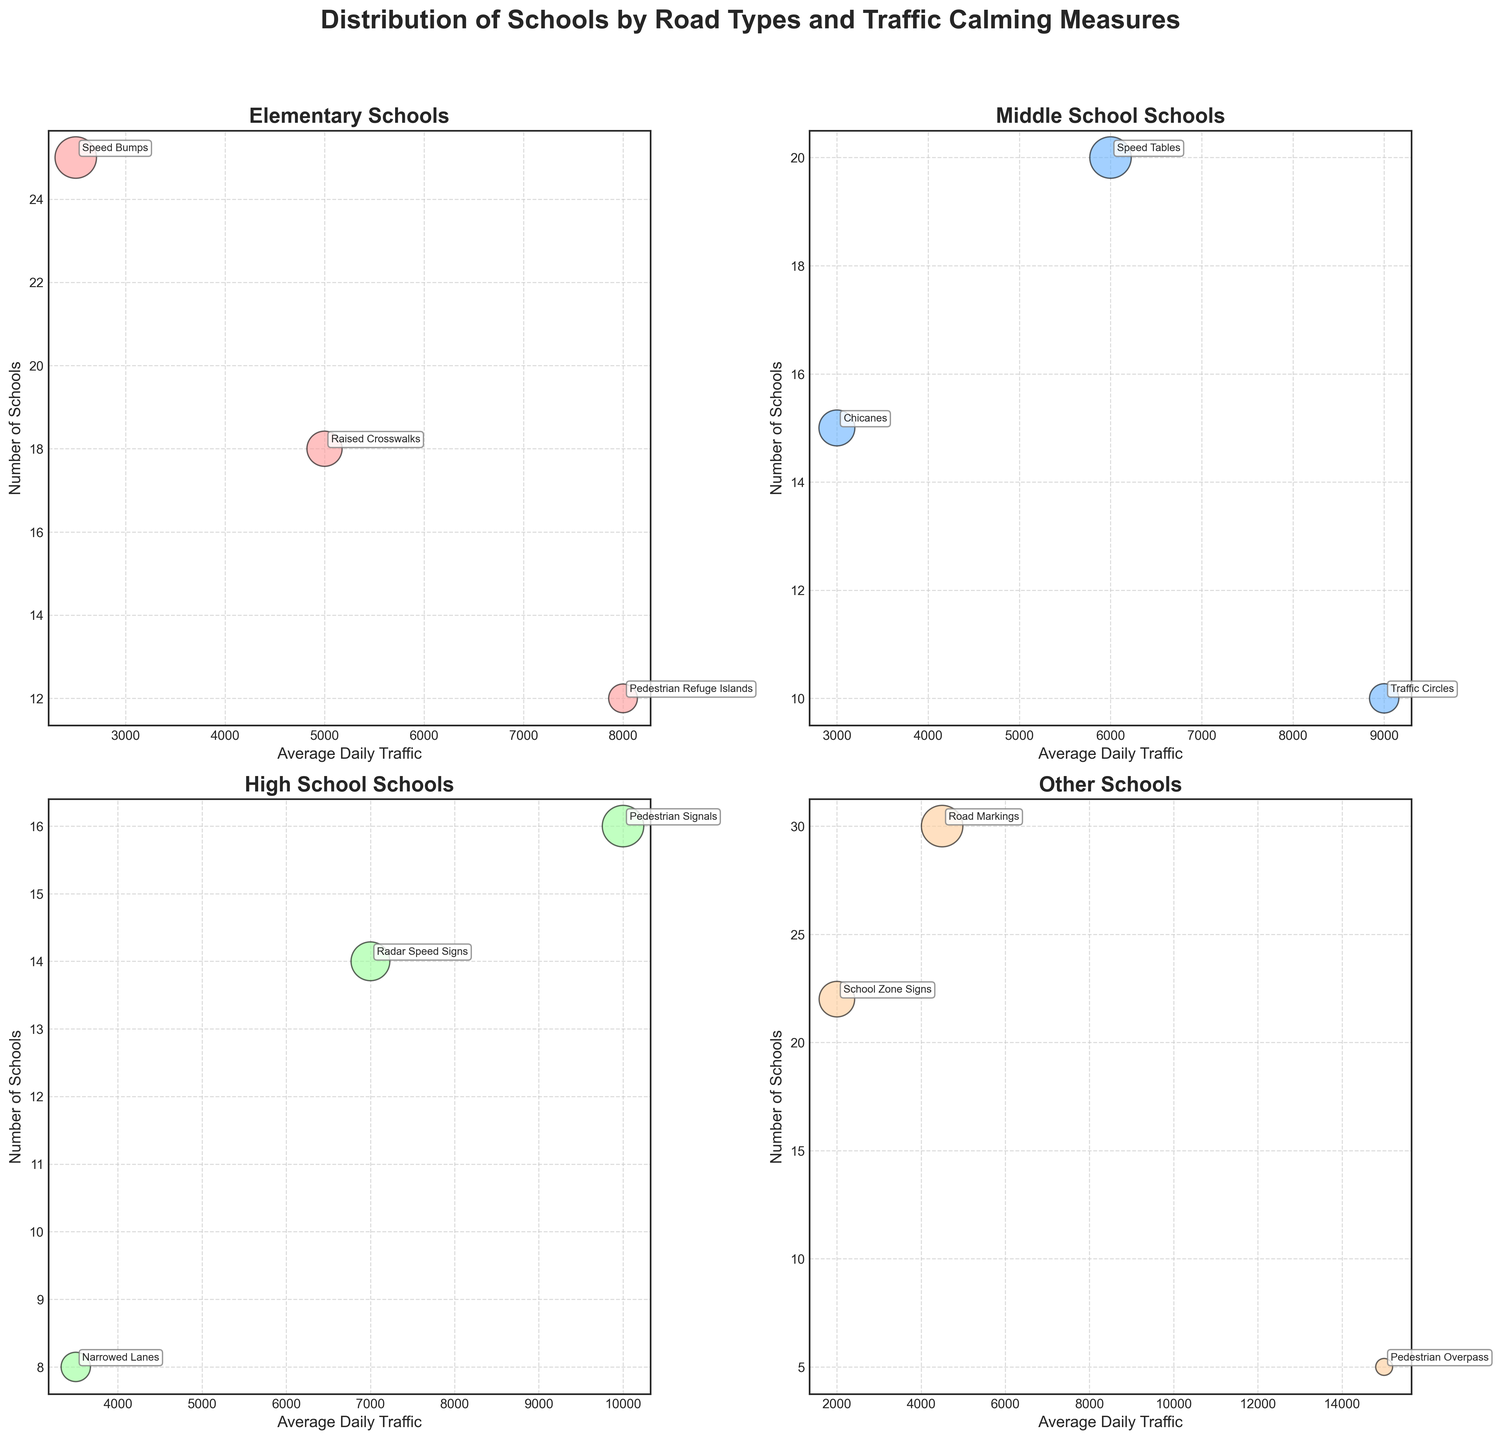What is the title of the figure? The title of the figure is located at the top and it is typically in a larger and bolder font to highlight its importance.
Answer: Distribution of Schools by Road Types and Traffic Calming Measures How many types of schools are represented? Different types of schools are indicated in the figure, each with its own sub-plot title. Counting these titles will give the number of school types.
Answer: Four Which road type has the highest average daily traffic? By scanning the x-axes across all sub-plots, identify the road type with the highest value on the average daily traffic scale.
Answer: Highway What traffic calming measure is used most frequently for Middle Schools? This can be determined by looking at the y-axis values in the Middle Schools sub-plot and checking the annotation on bubbles with the highest 'Number of Schools'.
Answer: Speed Tables Compare the number of high schools on residential streets to those on arterial roads. By looking at the High Schools sub-plot, compare the size of the bubbles (which indicates numbers) and the y-axis values for both Residential Streets and Arterial Roads.
Answer: 8 on Residential Streets, 16 on Arterial Roads Which type of school has the most types of road environments represented in the plots? By counting the unique road types mentioned in each sub-plot, determine which type of school has the widest variety.
Answer: Elementary For which school type does the traffic calming measure with the greatest number of schools appear? Identify which sub-plot has the largest bubble, then check the y-axis value and the associated traffic calming measure.
Answer: Secondary How does the use of pedestrian-related traffic calming measures compare between elementary and high schools? Look for annotated traffic calming measures related to pedestrians (e.g., Pedestrian Refuge Islands, Pedestrian Signals) in both Elementary and High Schools sub-plots and compare the bubble sizes/y-axis values.
Answer: Elementary: Pedestrian Refuge Islands (12), High School: Pedestrian Signals (16) What is the traffic calming measure used on the highway, and what is its corresponding average daily traffic? Refer to the sub-plot discussing non-standard school types (Others) and look at the annotations and x-axis values for the bubble representing the highway.
Answer: Pedestrian Overpass, 15,000 Which type of road is associated with the greatest number of schools in the Secondary school category? Refer to the Secondary school sub-plot and identify the road type corresponding to the highest value on the y-axis.
Answer: Urban Street 